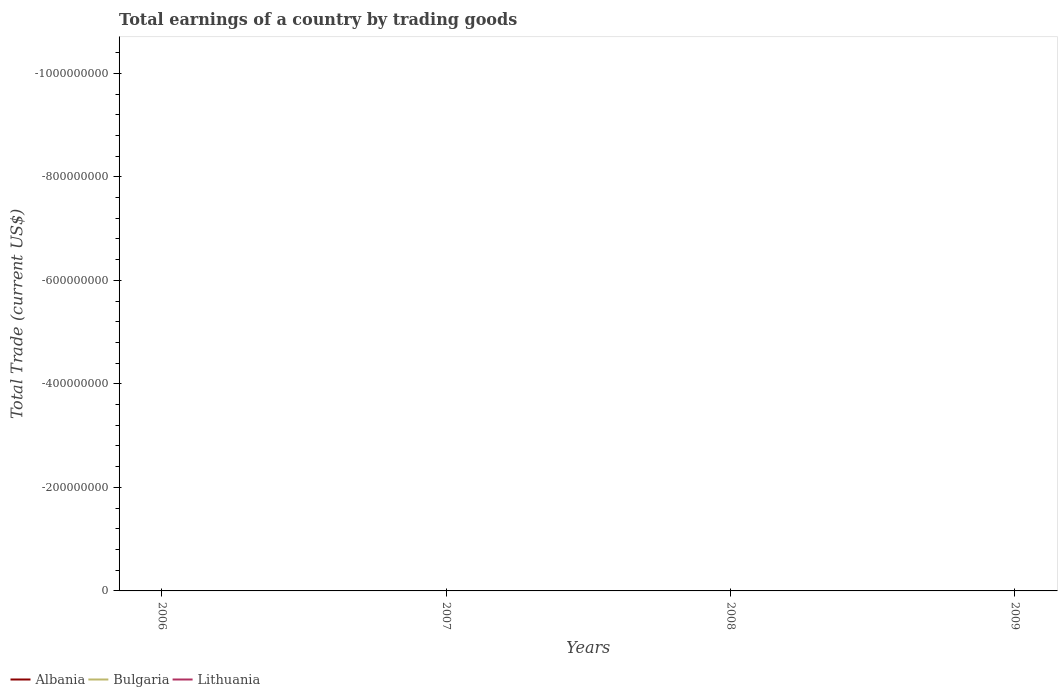Across all years, what is the maximum total earnings in Albania?
Provide a short and direct response. 0. Is the total earnings in Lithuania strictly greater than the total earnings in Albania over the years?
Make the answer very short. No. How many lines are there?
Keep it short and to the point. 0. How many years are there in the graph?
Offer a terse response. 4. What is the difference between two consecutive major ticks on the Y-axis?
Your answer should be compact. 2.00e+08. How many legend labels are there?
Provide a short and direct response. 3. How are the legend labels stacked?
Make the answer very short. Horizontal. What is the title of the graph?
Your answer should be compact. Total earnings of a country by trading goods. Does "Middle income" appear as one of the legend labels in the graph?
Your response must be concise. No. What is the label or title of the X-axis?
Keep it short and to the point. Years. What is the label or title of the Y-axis?
Provide a short and direct response. Total Trade (current US$). What is the Total Trade (current US$) in Albania in 2006?
Ensure brevity in your answer.  0. What is the Total Trade (current US$) of Albania in 2007?
Your answer should be compact. 0. What is the Total Trade (current US$) in Bulgaria in 2007?
Offer a terse response. 0. What is the Total Trade (current US$) of Albania in 2009?
Your answer should be compact. 0. What is the Total Trade (current US$) of Bulgaria in 2009?
Give a very brief answer. 0. What is the Total Trade (current US$) of Lithuania in 2009?
Keep it short and to the point. 0. What is the average Total Trade (current US$) of Albania per year?
Your response must be concise. 0. 